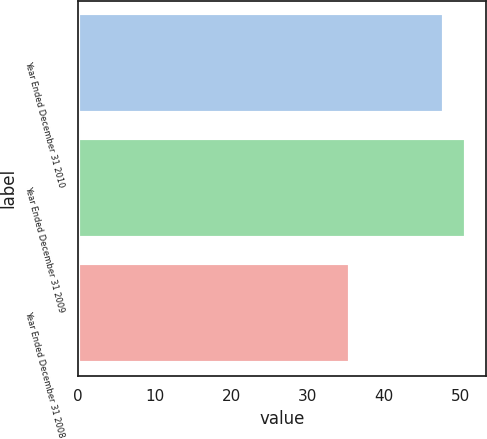Convert chart to OTSL. <chart><loc_0><loc_0><loc_500><loc_500><bar_chart><fcel>Year Ended December 31 2010<fcel>Year Ended December 31 2009<fcel>Year Ended December 31 2008<nl><fcel>47.9<fcel>50.8<fcel>35.6<nl></chart> 